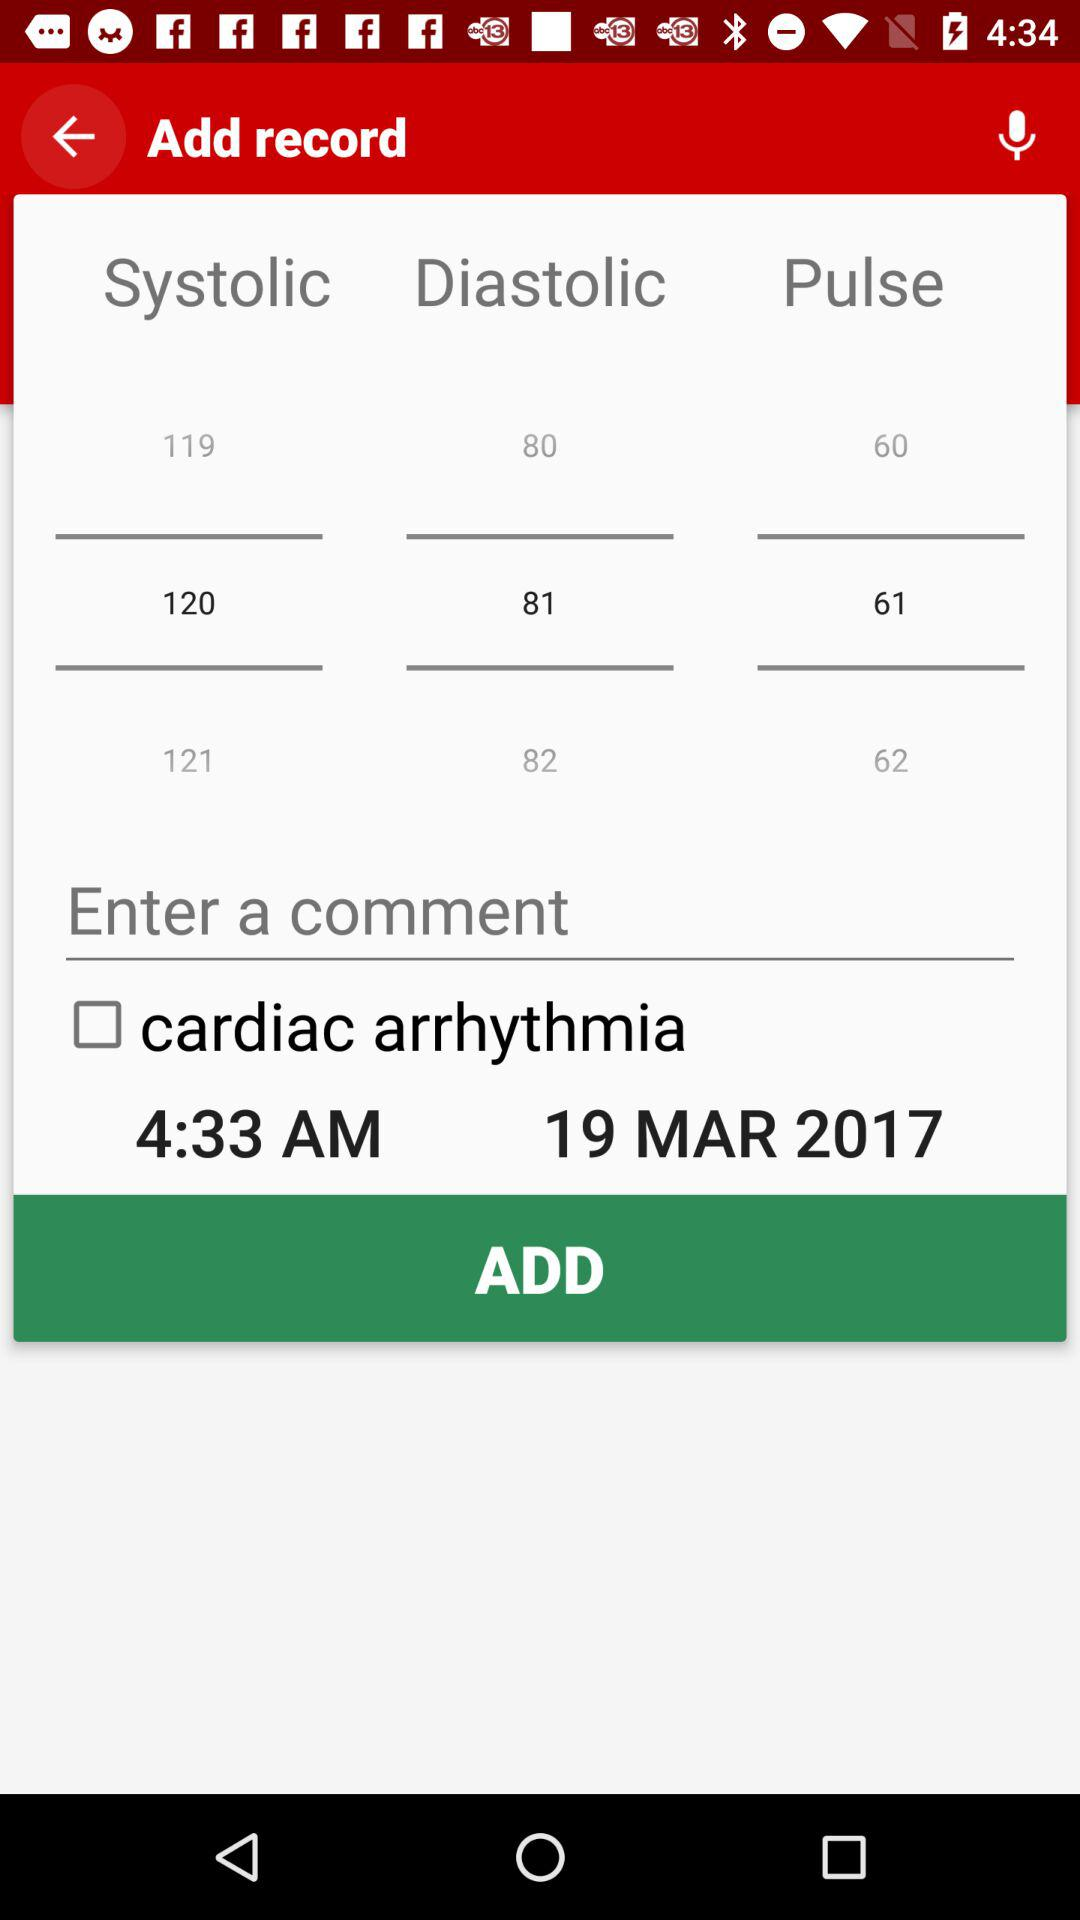What is the selected diastolic value? The selected value is 81. 